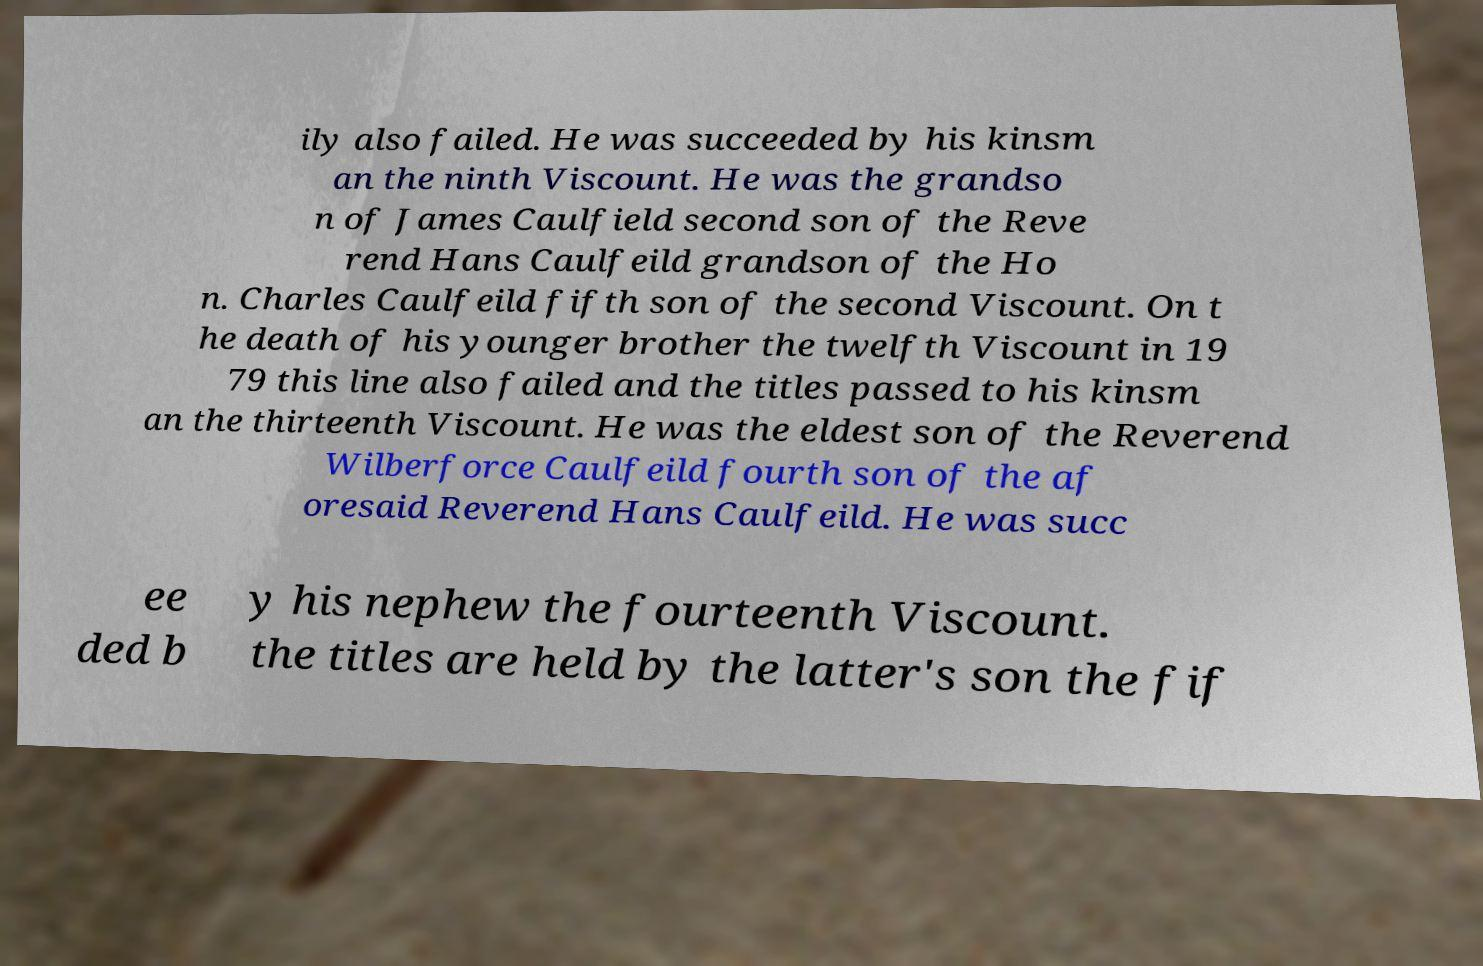Could you extract and type out the text from this image? ily also failed. He was succeeded by his kinsm an the ninth Viscount. He was the grandso n of James Caulfield second son of the Reve rend Hans Caulfeild grandson of the Ho n. Charles Caulfeild fifth son of the second Viscount. On t he death of his younger brother the twelfth Viscount in 19 79 this line also failed and the titles passed to his kinsm an the thirteenth Viscount. He was the eldest son of the Reverend Wilberforce Caulfeild fourth son of the af oresaid Reverend Hans Caulfeild. He was succ ee ded b y his nephew the fourteenth Viscount. the titles are held by the latter's son the fif 